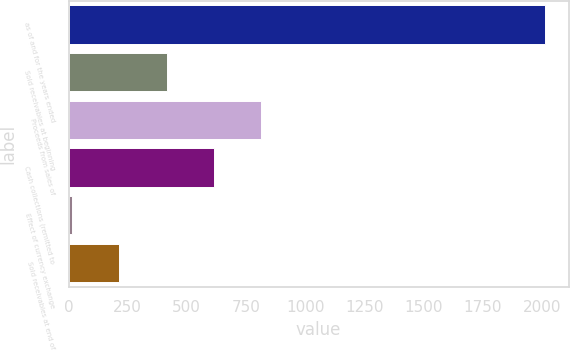<chart> <loc_0><loc_0><loc_500><loc_500><bar_chart><fcel>as of and for the years ended<fcel>Sold receivables at beginning<fcel>Proceeds from sales of<fcel>Cash collections (remitted to<fcel>Effect of currency exchange<fcel>Sold receivables at end of<nl><fcel>2014<fcel>414.8<fcel>814.6<fcel>614.7<fcel>15<fcel>214.9<nl></chart> 